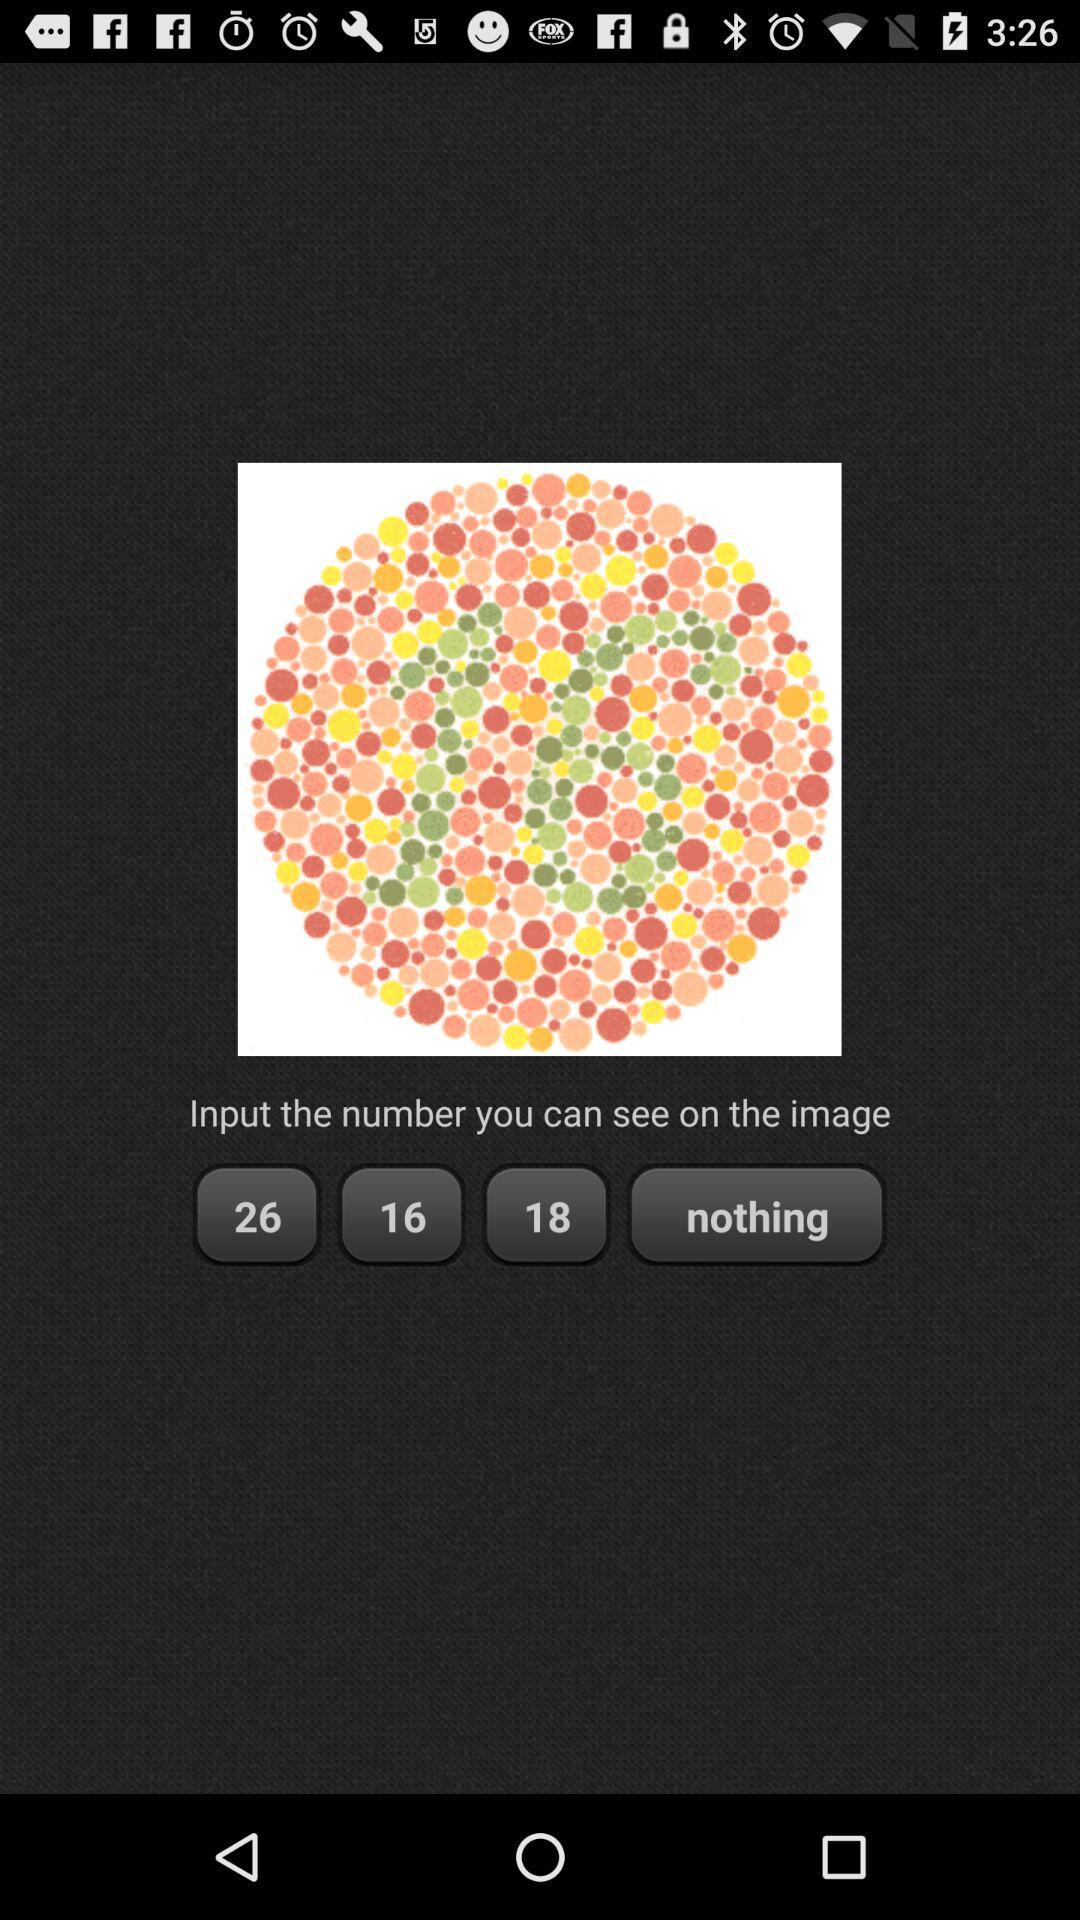What are the options given on the screen? On the screen, the options are 26, 16, 18, and nothing. 